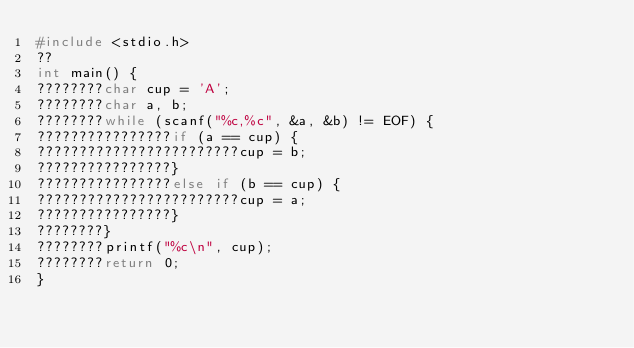Convert code to text. <code><loc_0><loc_0><loc_500><loc_500><_C_>#include <stdio.h>
??
int main() {
????????char cup = 'A';
????????char a, b;
????????while (scanf("%c,%c", &a, &b) != EOF) {
????????????????if (a == cup) {
????????????????????????cup = b;
????????????????}
????????????????else if (b == cup) {
????????????????????????cup = a;
????????????????}
????????}
????????printf("%c\n", cup);
????????return 0;
}</code> 